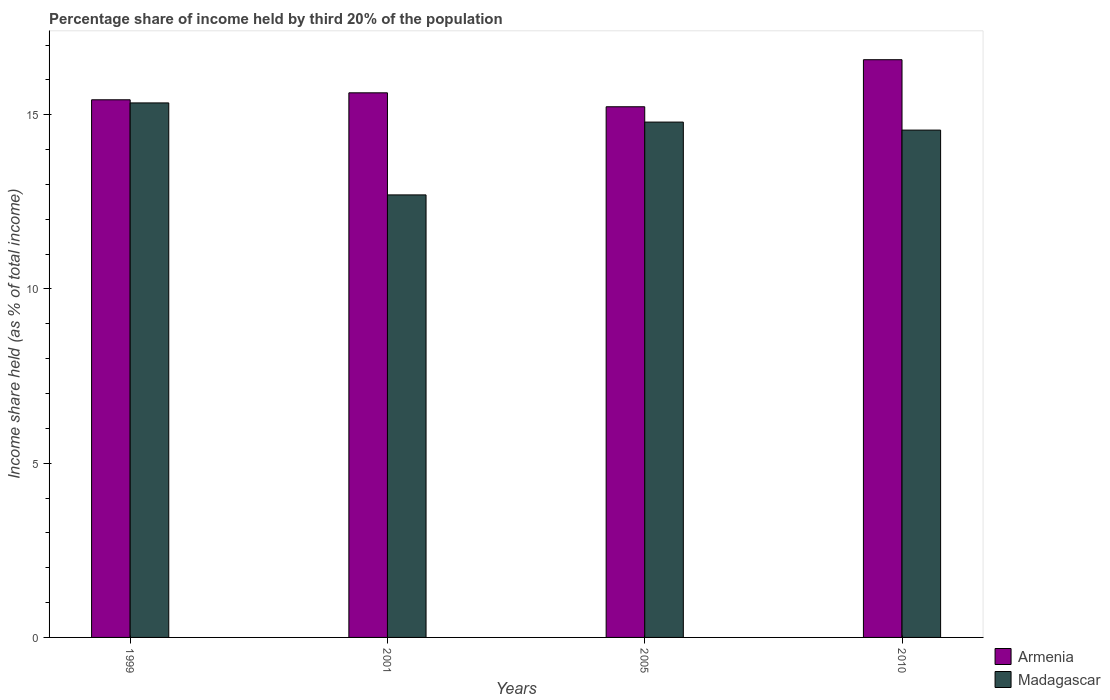How many different coloured bars are there?
Give a very brief answer. 2. How many groups of bars are there?
Your answer should be very brief. 4. Are the number of bars per tick equal to the number of legend labels?
Your response must be concise. Yes. How many bars are there on the 1st tick from the right?
Offer a very short reply. 2. What is the label of the 2nd group of bars from the left?
Give a very brief answer. 2001. In how many cases, is the number of bars for a given year not equal to the number of legend labels?
Ensure brevity in your answer.  0. What is the share of income held by third 20% of the population in Armenia in 2010?
Give a very brief answer. 16.58. Across all years, what is the maximum share of income held by third 20% of the population in Armenia?
Provide a short and direct response. 16.58. Across all years, what is the minimum share of income held by third 20% of the population in Madagascar?
Give a very brief answer. 12.7. What is the total share of income held by third 20% of the population in Armenia in the graph?
Make the answer very short. 62.87. What is the difference between the share of income held by third 20% of the population in Madagascar in 2005 and that in 2010?
Your response must be concise. 0.23. What is the difference between the share of income held by third 20% of the population in Madagascar in 2005 and the share of income held by third 20% of the population in Armenia in 1999?
Provide a short and direct response. -0.64. What is the average share of income held by third 20% of the population in Madagascar per year?
Offer a very short reply. 14.35. In the year 2005, what is the difference between the share of income held by third 20% of the population in Armenia and share of income held by third 20% of the population in Madagascar?
Make the answer very short. 0.44. In how many years, is the share of income held by third 20% of the population in Armenia greater than 5 %?
Make the answer very short. 4. What is the ratio of the share of income held by third 20% of the population in Armenia in 1999 to that in 2005?
Keep it short and to the point. 1.01. Is the difference between the share of income held by third 20% of the population in Armenia in 2001 and 2010 greater than the difference between the share of income held by third 20% of the population in Madagascar in 2001 and 2010?
Your answer should be compact. Yes. What is the difference between the highest and the second highest share of income held by third 20% of the population in Madagascar?
Your response must be concise. 0.55. What is the difference between the highest and the lowest share of income held by third 20% of the population in Madagascar?
Offer a very short reply. 2.64. In how many years, is the share of income held by third 20% of the population in Armenia greater than the average share of income held by third 20% of the population in Armenia taken over all years?
Keep it short and to the point. 1. What does the 2nd bar from the left in 2010 represents?
Ensure brevity in your answer.  Madagascar. What does the 2nd bar from the right in 1999 represents?
Your response must be concise. Armenia. Are the values on the major ticks of Y-axis written in scientific E-notation?
Ensure brevity in your answer.  No. Does the graph contain grids?
Your response must be concise. No. Where does the legend appear in the graph?
Provide a succinct answer. Bottom right. How many legend labels are there?
Make the answer very short. 2. What is the title of the graph?
Your answer should be compact. Percentage share of income held by third 20% of the population. What is the label or title of the Y-axis?
Provide a succinct answer. Income share held (as % of total income). What is the Income share held (as % of total income) of Armenia in 1999?
Ensure brevity in your answer.  15.43. What is the Income share held (as % of total income) in Madagascar in 1999?
Make the answer very short. 15.34. What is the Income share held (as % of total income) of Armenia in 2001?
Keep it short and to the point. 15.63. What is the Income share held (as % of total income) of Armenia in 2005?
Your answer should be compact. 15.23. What is the Income share held (as % of total income) in Madagascar in 2005?
Your response must be concise. 14.79. What is the Income share held (as % of total income) in Armenia in 2010?
Provide a short and direct response. 16.58. What is the Income share held (as % of total income) of Madagascar in 2010?
Provide a succinct answer. 14.56. Across all years, what is the maximum Income share held (as % of total income) in Armenia?
Ensure brevity in your answer.  16.58. Across all years, what is the maximum Income share held (as % of total income) in Madagascar?
Your answer should be compact. 15.34. Across all years, what is the minimum Income share held (as % of total income) in Armenia?
Offer a very short reply. 15.23. Across all years, what is the minimum Income share held (as % of total income) in Madagascar?
Provide a succinct answer. 12.7. What is the total Income share held (as % of total income) of Armenia in the graph?
Keep it short and to the point. 62.87. What is the total Income share held (as % of total income) of Madagascar in the graph?
Ensure brevity in your answer.  57.39. What is the difference between the Income share held (as % of total income) of Madagascar in 1999 and that in 2001?
Make the answer very short. 2.64. What is the difference between the Income share held (as % of total income) of Armenia in 1999 and that in 2005?
Ensure brevity in your answer.  0.2. What is the difference between the Income share held (as % of total income) in Madagascar in 1999 and that in 2005?
Offer a terse response. 0.55. What is the difference between the Income share held (as % of total income) of Armenia in 1999 and that in 2010?
Give a very brief answer. -1.15. What is the difference between the Income share held (as % of total income) of Madagascar in 1999 and that in 2010?
Offer a very short reply. 0.78. What is the difference between the Income share held (as % of total income) in Madagascar in 2001 and that in 2005?
Ensure brevity in your answer.  -2.09. What is the difference between the Income share held (as % of total income) of Armenia in 2001 and that in 2010?
Your answer should be compact. -0.95. What is the difference between the Income share held (as % of total income) of Madagascar in 2001 and that in 2010?
Keep it short and to the point. -1.86. What is the difference between the Income share held (as % of total income) in Armenia in 2005 and that in 2010?
Your answer should be compact. -1.35. What is the difference between the Income share held (as % of total income) in Madagascar in 2005 and that in 2010?
Provide a short and direct response. 0.23. What is the difference between the Income share held (as % of total income) of Armenia in 1999 and the Income share held (as % of total income) of Madagascar in 2001?
Offer a very short reply. 2.73. What is the difference between the Income share held (as % of total income) of Armenia in 1999 and the Income share held (as % of total income) of Madagascar in 2005?
Ensure brevity in your answer.  0.64. What is the difference between the Income share held (as % of total income) of Armenia in 1999 and the Income share held (as % of total income) of Madagascar in 2010?
Ensure brevity in your answer.  0.87. What is the difference between the Income share held (as % of total income) of Armenia in 2001 and the Income share held (as % of total income) of Madagascar in 2005?
Keep it short and to the point. 0.84. What is the difference between the Income share held (as % of total income) of Armenia in 2001 and the Income share held (as % of total income) of Madagascar in 2010?
Your answer should be compact. 1.07. What is the difference between the Income share held (as % of total income) in Armenia in 2005 and the Income share held (as % of total income) in Madagascar in 2010?
Give a very brief answer. 0.67. What is the average Income share held (as % of total income) in Armenia per year?
Offer a very short reply. 15.72. What is the average Income share held (as % of total income) in Madagascar per year?
Your answer should be very brief. 14.35. In the year 1999, what is the difference between the Income share held (as % of total income) in Armenia and Income share held (as % of total income) in Madagascar?
Your answer should be compact. 0.09. In the year 2001, what is the difference between the Income share held (as % of total income) of Armenia and Income share held (as % of total income) of Madagascar?
Provide a succinct answer. 2.93. In the year 2005, what is the difference between the Income share held (as % of total income) in Armenia and Income share held (as % of total income) in Madagascar?
Your answer should be very brief. 0.44. In the year 2010, what is the difference between the Income share held (as % of total income) in Armenia and Income share held (as % of total income) in Madagascar?
Offer a terse response. 2.02. What is the ratio of the Income share held (as % of total income) in Armenia in 1999 to that in 2001?
Give a very brief answer. 0.99. What is the ratio of the Income share held (as % of total income) in Madagascar in 1999 to that in 2001?
Give a very brief answer. 1.21. What is the ratio of the Income share held (as % of total income) in Armenia in 1999 to that in 2005?
Offer a terse response. 1.01. What is the ratio of the Income share held (as % of total income) of Madagascar in 1999 to that in 2005?
Provide a succinct answer. 1.04. What is the ratio of the Income share held (as % of total income) in Armenia in 1999 to that in 2010?
Your response must be concise. 0.93. What is the ratio of the Income share held (as % of total income) in Madagascar in 1999 to that in 2010?
Give a very brief answer. 1.05. What is the ratio of the Income share held (as % of total income) of Armenia in 2001 to that in 2005?
Ensure brevity in your answer.  1.03. What is the ratio of the Income share held (as % of total income) in Madagascar in 2001 to that in 2005?
Your answer should be very brief. 0.86. What is the ratio of the Income share held (as % of total income) of Armenia in 2001 to that in 2010?
Your response must be concise. 0.94. What is the ratio of the Income share held (as % of total income) in Madagascar in 2001 to that in 2010?
Ensure brevity in your answer.  0.87. What is the ratio of the Income share held (as % of total income) of Armenia in 2005 to that in 2010?
Keep it short and to the point. 0.92. What is the ratio of the Income share held (as % of total income) of Madagascar in 2005 to that in 2010?
Make the answer very short. 1.02. What is the difference between the highest and the second highest Income share held (as % of total income) in Madagascar?
Provide a succinct answer. 0.55. What is the difference between the highest and the lowest Income share held (as % of total income) of Armenia?
Offer a terse response. 1.35. What is the difference between the highest and the lowest Income share held (as % of total income) in Madagascar?
Your response must be concise. 2.64. 